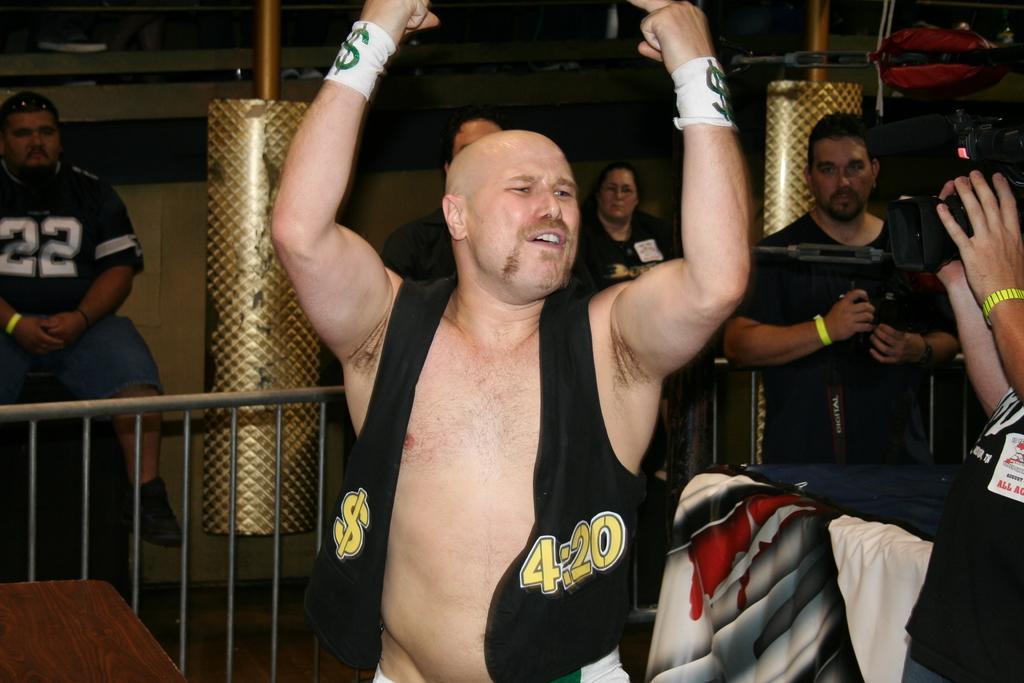Please provide a concise description of this image. In the image there is a man in the foreground and behind him there are some other people, in between the people there is a metal fencing. 